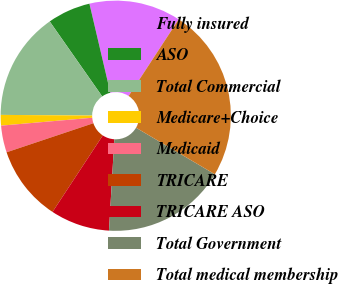Convert chart. <chart><loc_0><loc_0><loc_500><loc_500><pie_chart><fcel>Fully insured<fcel>ASO<fcel>Total Commercial<fcel>Medicare+Choice<fcel>Medicaid<fcel>TRICARE<fcel>TRICARE ASO<fcel>Total Government<fcel>Total medical membership<nl><fcel>12.88%<fcel>6.05%<fcel>15.16%<fcel>1.49%<fcel>3.77%<fcel>10.6%<fcel>8.32%<fcel>17.44%<fcel>24.28%<nl></chart> 